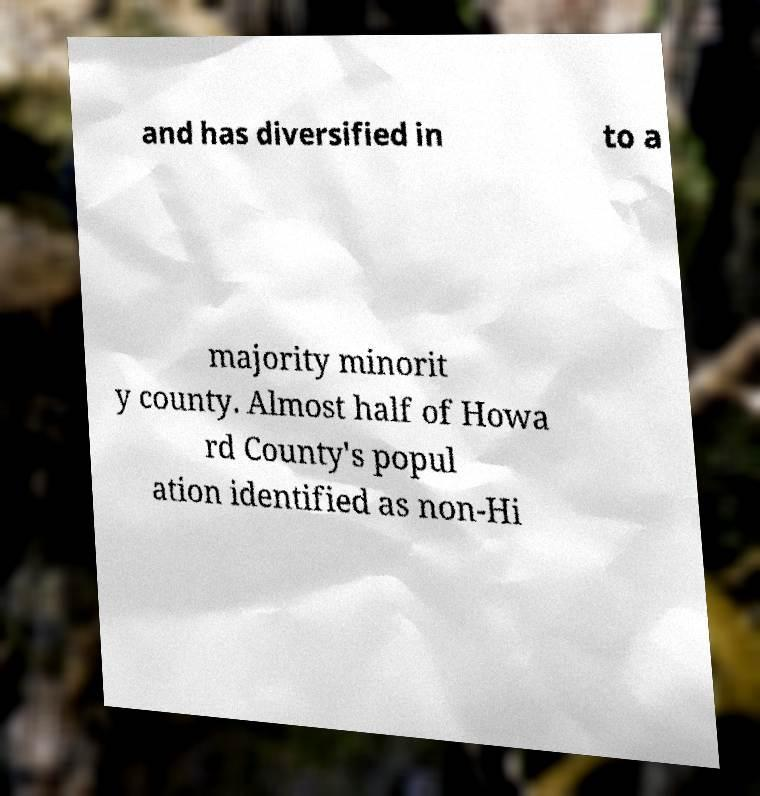What does it mean for a population to be identified as non-Hispanic? When a population is identified as non-Hispanic, it refers to those individuals who do not identify as Hispanic or Latino. This demographic labeling is crucial for socio-economic studies, policy making, and understanding cultural compositions within a region, as it helps differentiate the diverse groups forming the social fabric of the area. 